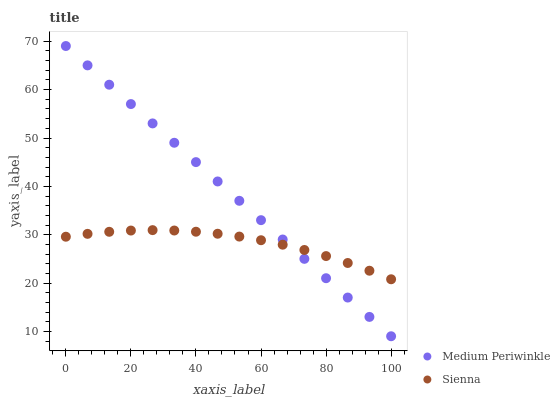Does Sienna have the minimum area under the curve?
Answer yes or no. Yes. Does Medium Periwinkle have the maximum area under the curve?
Answer yes or no. Yes. Does Medium Periwinkle have the minimum area under the curve?
Answer yes or no. No. Is Medium Periwinkle the smoothest?
Answer yes or no. Yes. Is Sienna the roughest?
Answer yes or no. Yes. Is Medium Periwinkle the roughest?
Answer yes or no. No. Does Medium Periwinkle have the lowest value?
Answer yes or no. Yes. Does Medium Periwinkle have the highest value?
Answer yes or no. Yes. Does Medium Periwinkle intersect Sienna?
Answer yes or no. Yes. Is Medium Periwinkle less than Sienna?
Answer yes or no. No. Is Medium Periwinkle greater than Sienna?
Answer yes or no. No. 